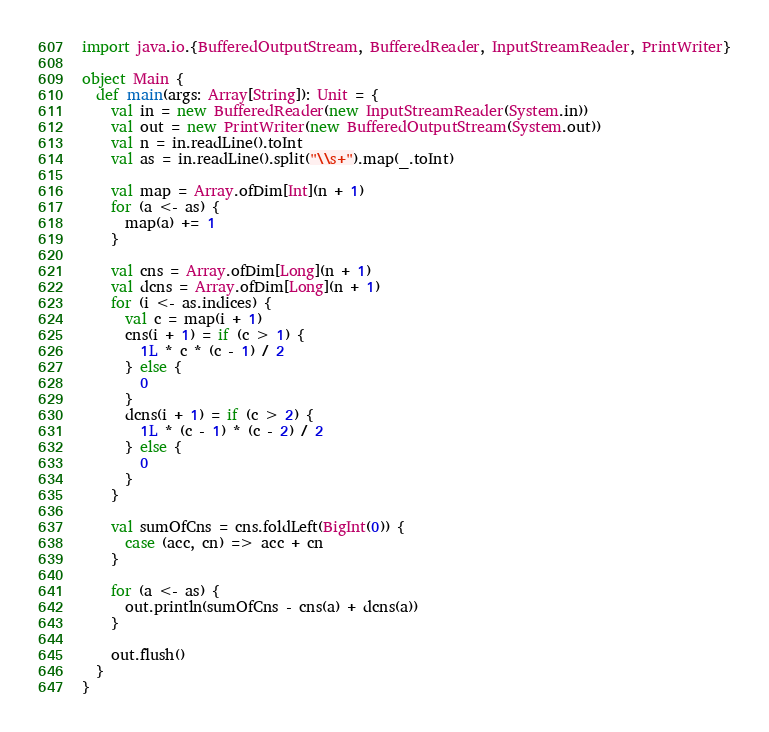<code> <loc_0><loc_0><loc_500><loc_500><_Scala_>import java.io.{BufferedOutputStream, BufferedReader, InputStreamReader, PrintWriter}

object Main {
  def main(args: Array[String]): Unit = {
    val in = new BufferedReader(new InputStreamReader(System.in))
    val out = new PrintWriter(new BufferedOutputStream(System.out))
    val n = in.readLine().toInt
    val as = in.readLine().split("\\s+").map(_.toInt)

    val map = Array.ofDim[Int](n + 1)
    for (a <- as) {
      map(a) += 1
    }

    val cns = Array.ofDim[Long](n + 1)
    val dcns = Array.ofDim[Long](n + 1)
    for (i <- as.indices) {
      val c = map(i + 1)
      cns(i + 1) = if (c > 1) {
        1L * c * (c - 1) / 2
      } else {
        0
      }
      dcns(i + 1) = if (c > 2) {
        1L * (c - 1) * (c - 2) / 2
      } else {
        0
      }
    }

    val sumOfCns = cns.foldLeft(BigInt(0)) {
      case (acc, cn) => acc + cn
    }

    for (a <- as) {
      out.println(sumOfCns - cns(a) + dcns(a))
    }

    out.flush()
  }
}
</code> 